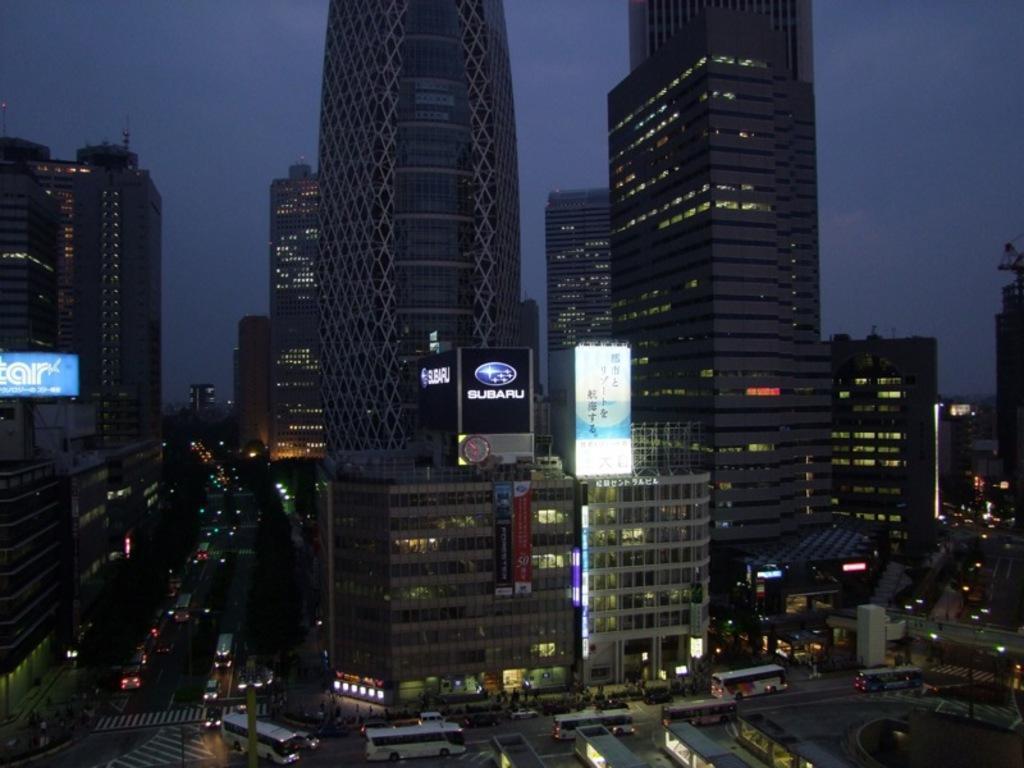How would you summarize this image in a sentence or two? This is the picture of a city. In this image there are buildings and trees and poles and there are hoardings on the buildings. At the bottom there are vehicles and there are group of people on the road. At the top there is sky. 